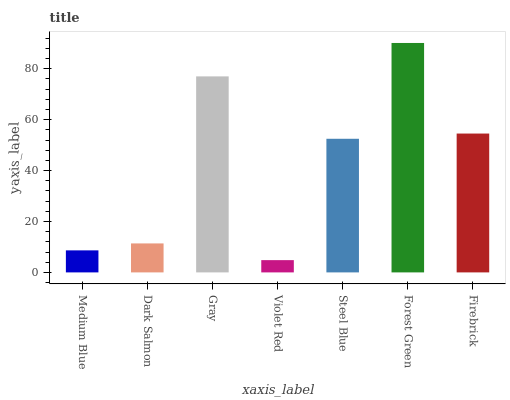Is Violet Red the minimum?
Answer yes or no. Yes. Is Forest Green the maximum?
Answer yes or no. Yes. Is Dark Salmon the minimum?
Answer yes or no. No. Is Dark Salmon the maximum?
Answer yes or no. No. Is Dark Salmon greater than Medium Blue?
Answer yes or no. Yes. Is Medium Blue less than Dark Salmon?
Answer yes or no. Yes. Is Medium Blue greater than Dark Salmon?
Answer yes or no. No. Is Dark Salmon less than Medium Blue?
Answer yes or no. No. Is Steel Blue the high median?
Answer yes or no. Yes. Is Steel Blue the low median?
Answer yes or no. Yes. Is Gray the high median?
Answer yes or no. No. Is Medium Blue the low median?
Answer yes or no. No. 